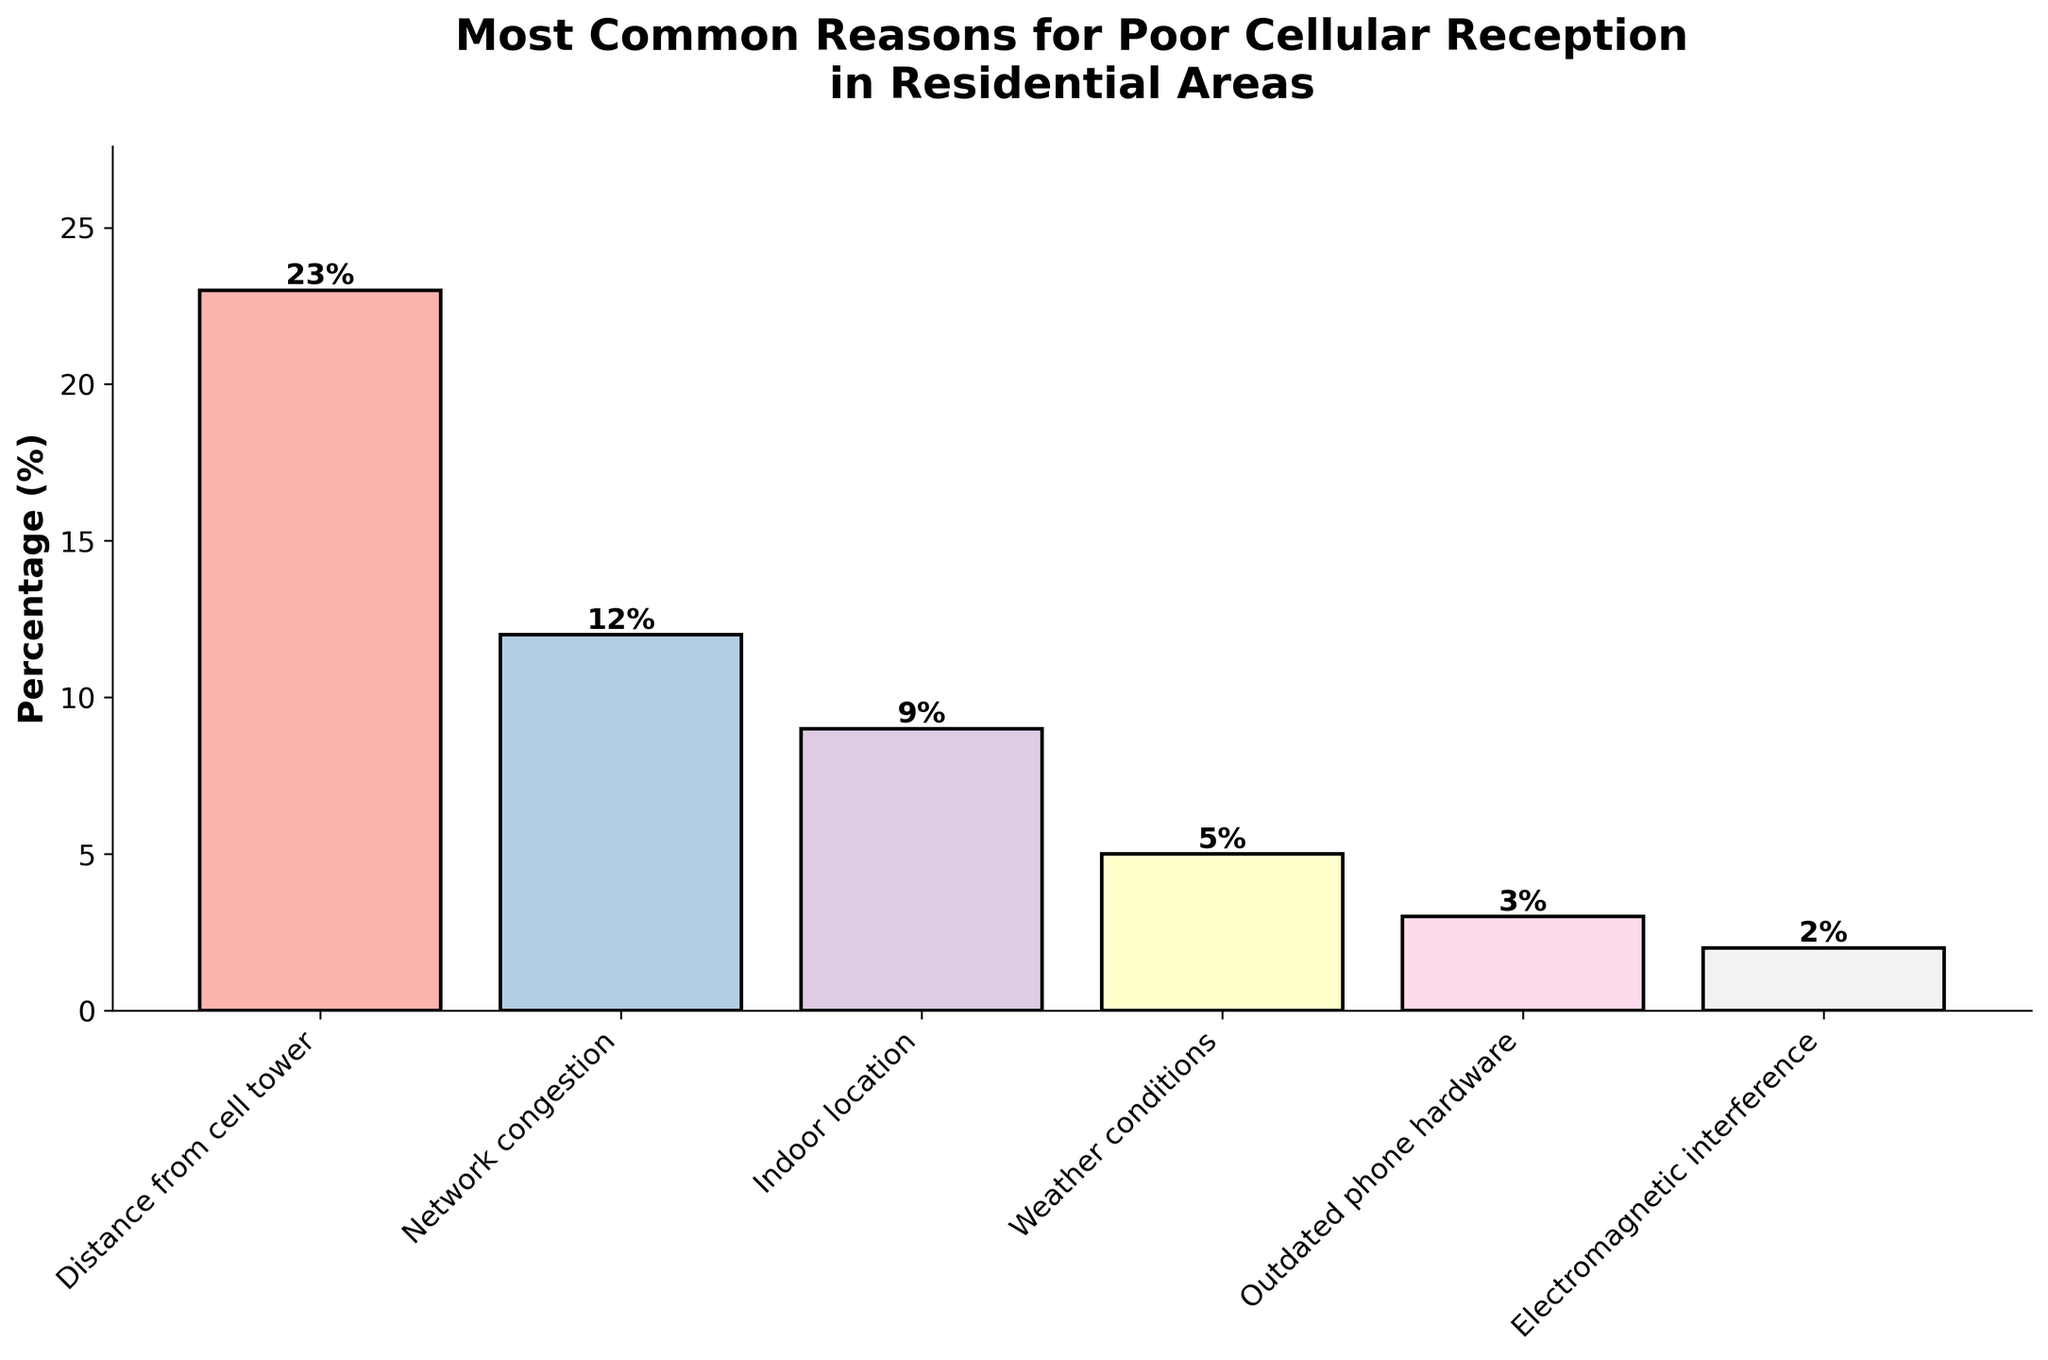Which reason for poor cellular reception is the most common? The figure shows that "Distance from cell tower" has the highest percentage bar.
Answer: Distance from cell tower Which reason has the lowest percentage for poor cellular reception? The lowest percentage bar is labeled "Electromagnetic interference."
Answer: Electromagnetic interference What is the percentage difference between the most and least common reasons for poor cellular reception? The most common reason, "Distance from cell tower," has a percentage of 23%, and the least common reason, "Electromagnetic interference," has 2%. The difference is 23% - 2% = 21%.
Answer: 21% What is the combined percentage of indoor location and weather conditions contributing to poor cellular reception? The percentage for "Indoor location" is 9%, and for "Weather conditions" it is 5%. The combined percentage is 9% + 5% = 14%.
Answer: 14% Is the percentage of outdated phone hardware contributing to poor cellular reception more or less than half the percentage of network congestion? The percentage for "Outdated phone hardware" is 3%, and for "Network congestion" it is 12%. Half of network congestion is 12% / 2 = 6%. Since 3% is less than 6%, outdated phone hardware contributes less than half the percentage of network congestion.
Answer: Less Which reason, between indoor location and outdated phone hardware, contributes more to poor cellular reception? By comparing the heights of the bars, "Indoor location" (9%) is higher than "Outdated phone hardware" (3%).
Answer: Indoor location What is the average percentage of the reasons contributing to poor cellular reception listed in the figure? To find the average, sum all the percentages: 23% + 12% + 9% + 5% + 3% + 2% = 54%. Then divide by the number of reasons: 54% / 6 = 9%.
Answer: 9% Which reason is represented by the tallest bar in the figure? The tallest bar visually corresponds to "Distance from cell tower."
Answer: Distance from cell tower If we combine the percentages of network congestion and electromagnetic interference, does their combined contribution exceed that of distance from cell tower? The percentage for "Network congestion" is 12% and for "Electromagnetic interference" is 2%. Their combined contribution is 12% + 2% = 14%, which is less than the 23% for "Distance from cell tower."
Answer: No What is the percentage difference between the second most common and the second least common reasons for poor cellular reception? The second most common reason is "Network congestion" with 12%, and the second least common is "Weather conditions" with 5%. The difference is 12% - 5% = 7%.
Answer: 7% 